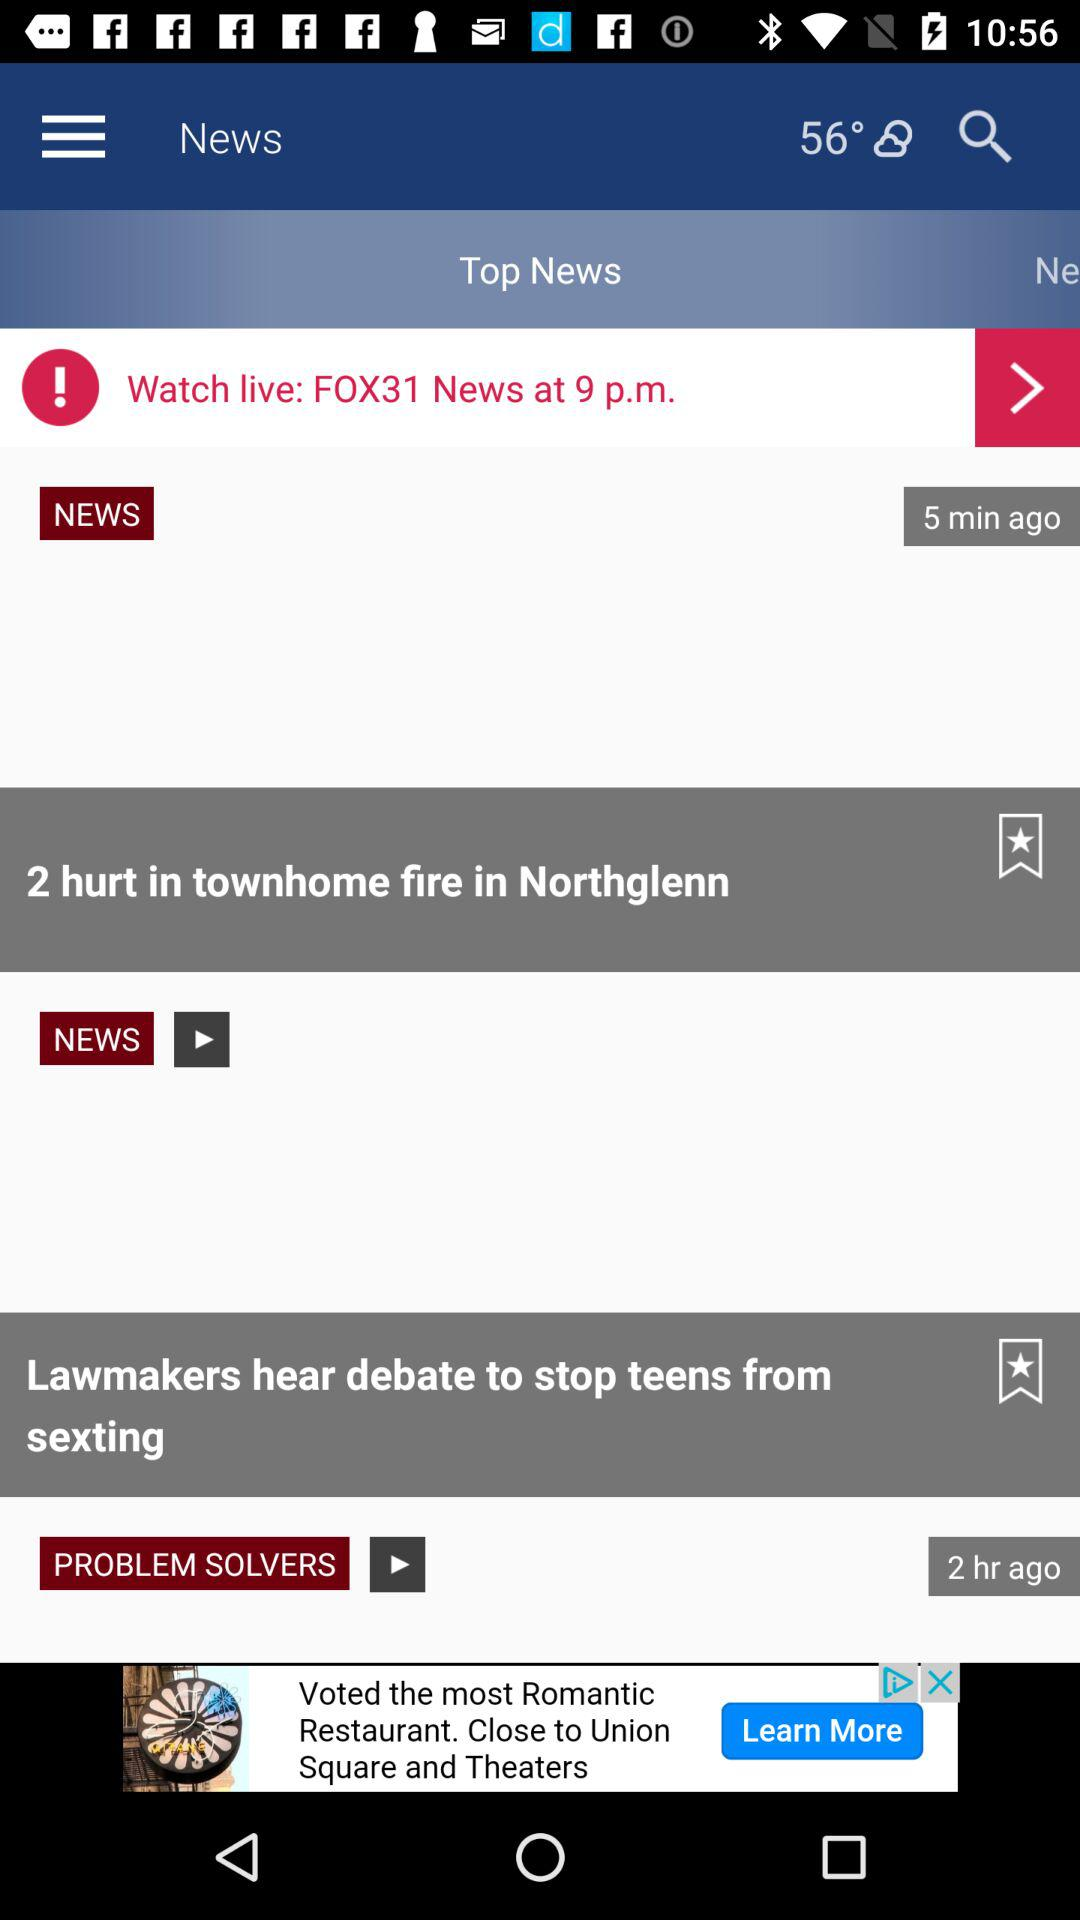When was the news Watch live: FOX31 news at 9p.m posted?
When the provided information is insufficient, respond with <no answer>. <no answer> 